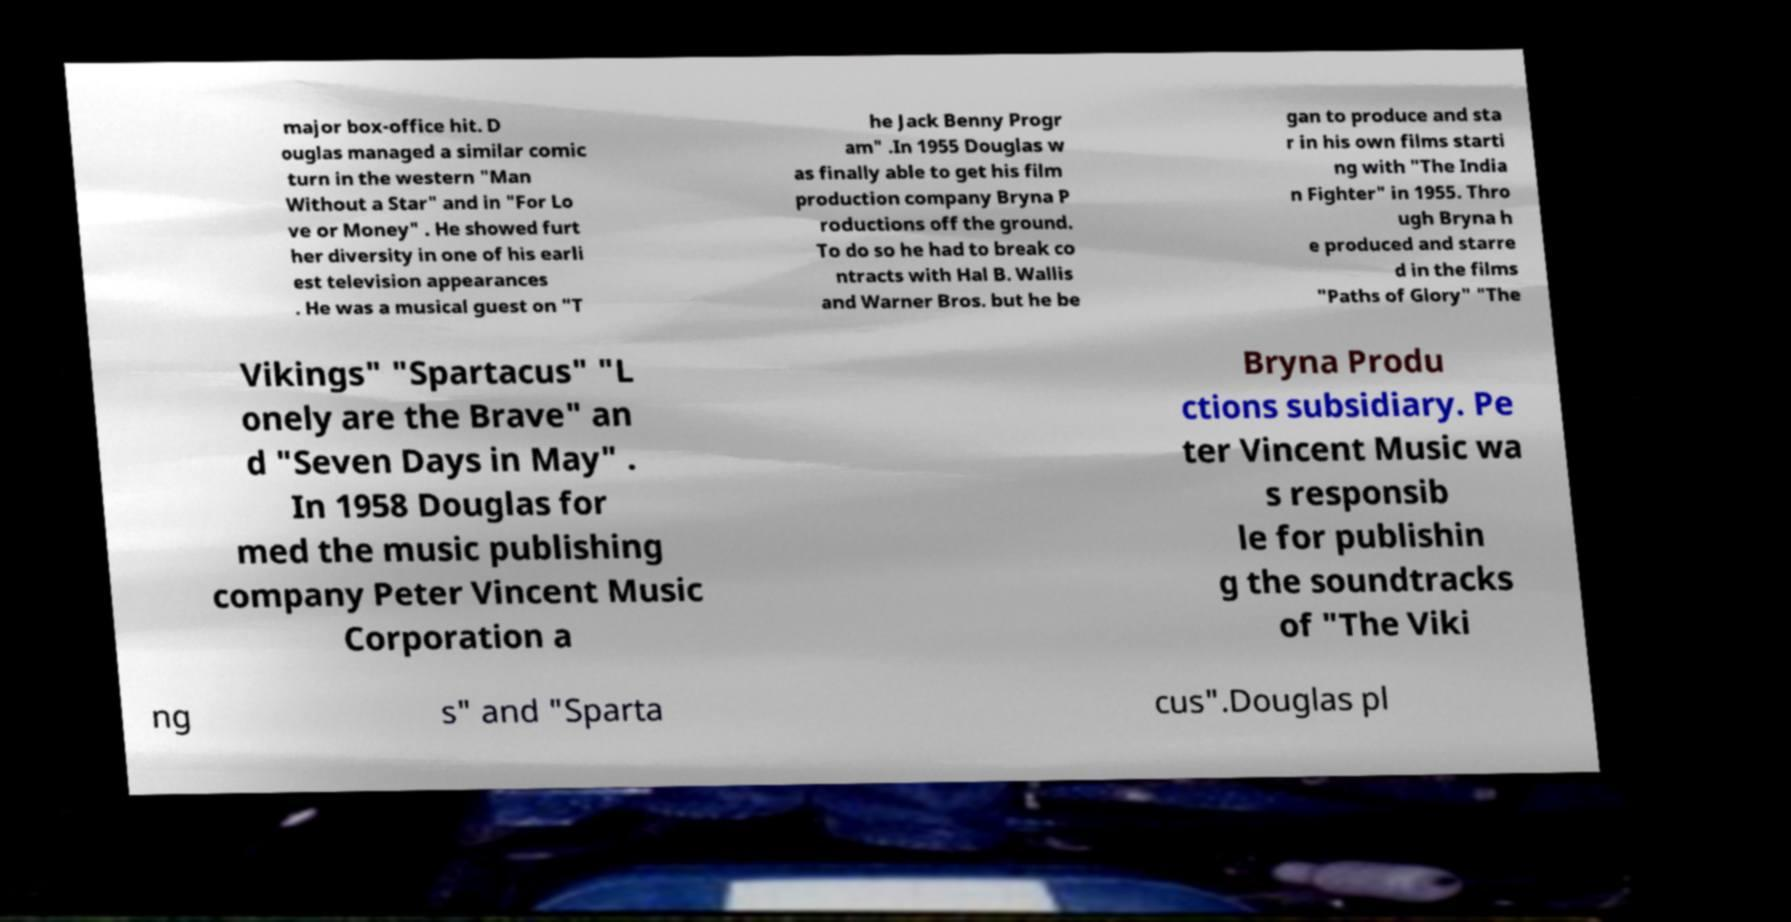Can you read and provide the text displayed in the image?This photo seems to have some interesting text. Can you extract and type it out for me? major box-office hit. D ouglas managed a similar comic turn in the western "Man Without a Star" and in "For Lo ve or Money" . He showed furt her diversity in one of his earli est television appearances . He was a musical guest on "T he Jack Benny Progr am" .In 1955 Douglas w as finally able to get his film production company Bryna P roductions off the ground. To do so he had to break co ntracts with Hal B. Wallis and Warner Bros. but he be gan to produce and sta r in his own films starti ng with "The India n Fighter" in 1955. Thro ugh Bryna h e produced and starre d in the films "Paths of Glory" "The Vikings" "Spartacus" "L onely are the Brave" an d "Seven Days in May" . In 1958 Douglas for med the music publishing company Peter Vincent Music Corporation a Bryna Produ ctions subsidiary. Pe ter Vincent Music wa s responsib le for publishin g the soundtracks of "The Viki ng s" and "Sparta cus".Douglas pl 